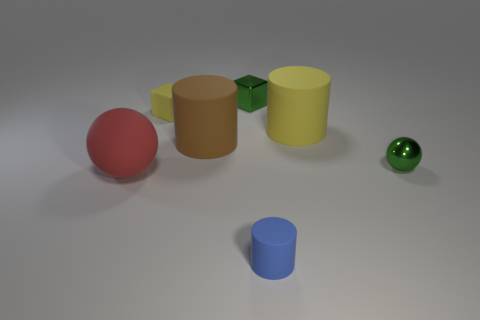What is the tiny green cube made of?
Provide a short and direct response. Metal. Are there more yellow matte things that are behind the green sphere than large yellow cylinders?
Offer a terse response. Yes. What number of tiny green shiny balls are left of the object left of the small matte object behind the large yellow matte thing?
Keep it short and to the point. 0. There is a small object that is right of the tiny yellow matte thing and behind the tiny metal ball; what is its material?
Provide a succinct answer. Metal. The small sphere is what color?
Provide a short and direct response. Green. Is the number of small things in front of the matte sphere greater than the number of rubber balls to the right of the tiny yellow rubber block?
Give a very brief answer. Yes. There is a metal thing that is behind the small ball; what is its color?
Make the answer very short. Green. There is a rubber object left of the rubber cube; is it the same size as the green object that is on the right side of the green block?
Give a very brief answer. No. How many objects are tiny blue rubber cylinders or red rubber things?
Offer a terse response. 2. What material is the tiny object that is in front of the sphere in front of the green ball?
Your response must be concise. Rubber. 